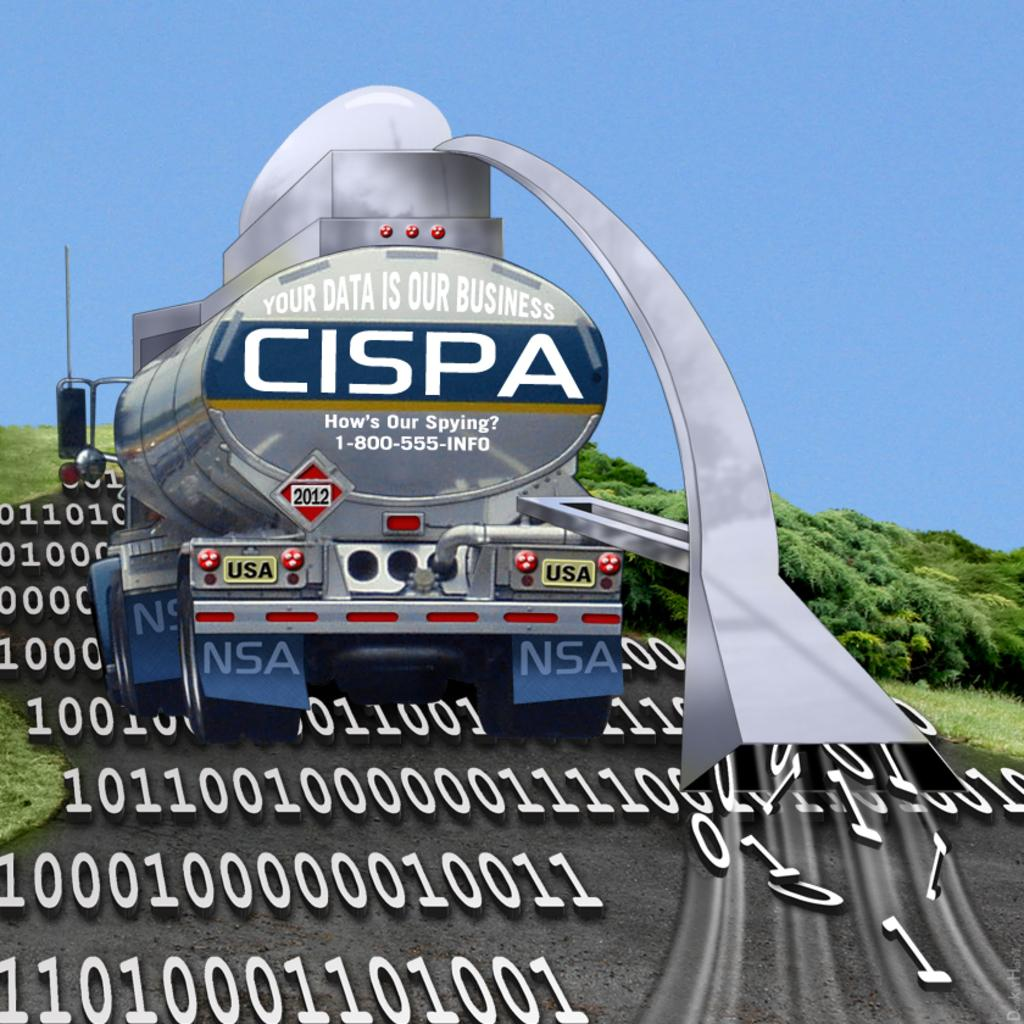What is on the road in the image? There is a vehicle on the road in the image. What else can be seen in the image besides the vehicle? Numbers, grass, trees, and the sky are visible in the image. How can you tell that the image might be an edited photo? The image appears to be an edited photo, as indicated by the provided fact. What type of farm animals can be seen grazing in the image? There are no farm animals present in the image. Can you describe the camping equipment visible in the image? There is no camping equipment visible in the image. 